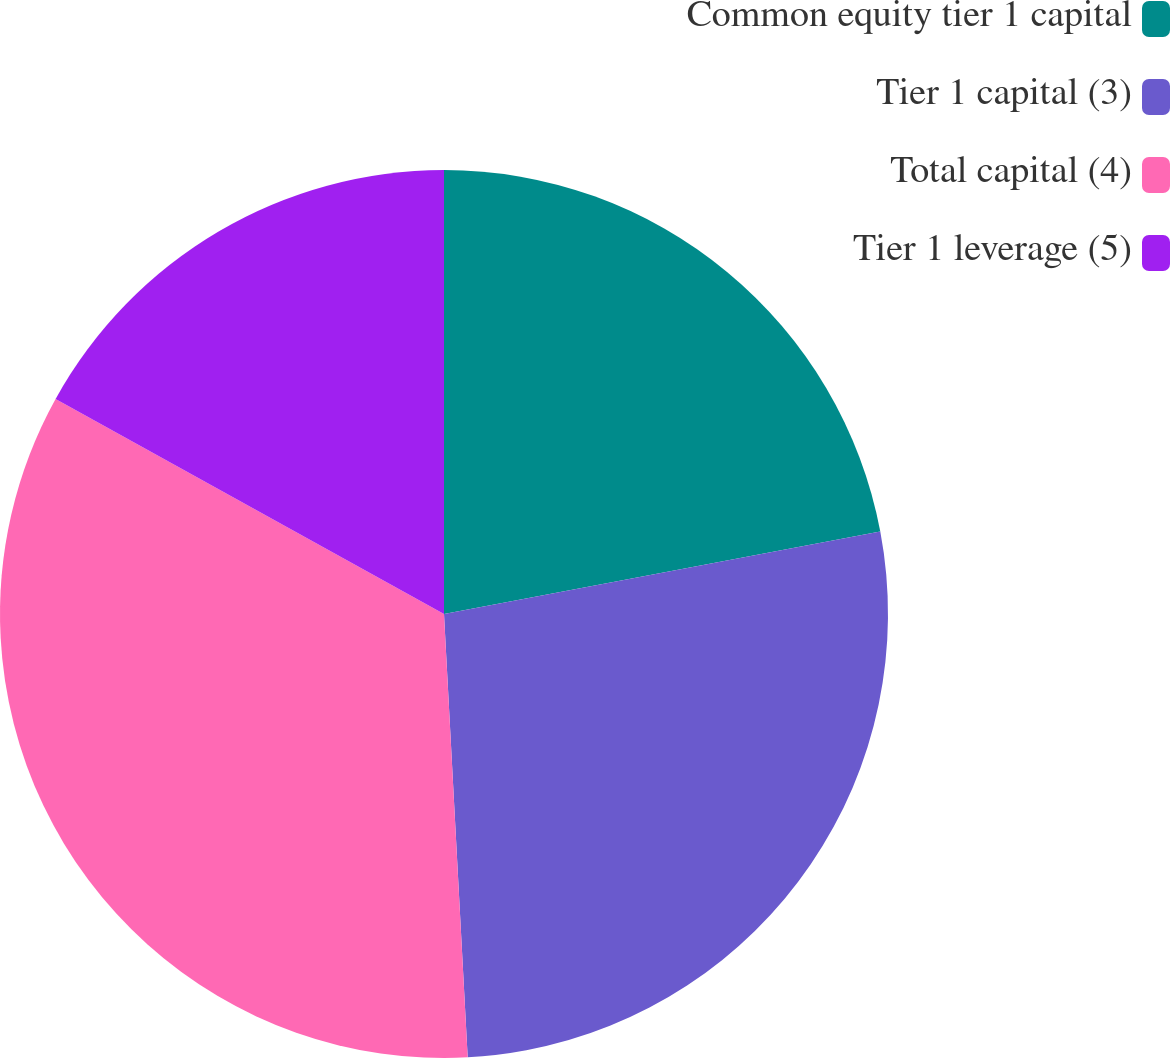<chart> <loc_0><loc_0><loc_500><loc_500><pie_chart><fcel>Common equity tier 1 capital<fcel>Tier 1 capital (3)<fcel>Total capital (4)<fcel>Tier 1 leverage (5)<nl><fcel>22.03%<fcel>27.12%<fcel>33.9%<fcel>16.95%<nl></chart> 